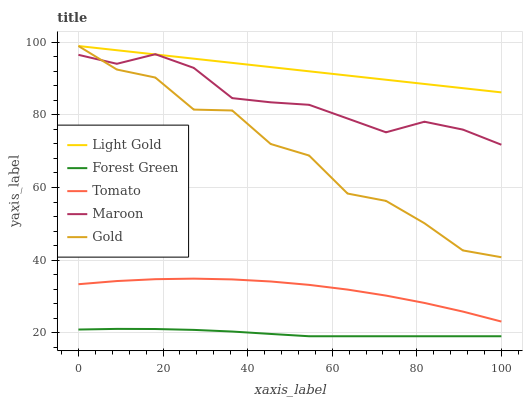Does Forest Green have the minimum area under the curve?
Answer yes or no. Yes. Does Light Gold have the maximum area under the curve?
Answer yes or no. Yes. Does Light Gold have the minimum area under the curve?
Answer yes or no. No. Does Forest Green have the maximum area under the curve?
Answer yes or no. No. Is Light Gold the smoothest?
Answer yes or no. Yes. Is Gold the roughest?
Answer yes or no. Yes. Is Forest Green the smoothest?
Answer yes or no. No. Is Forest Green the roughest?
Answer yes or no. No. Does Forest Green have the lowest value?
Answer yes or no. Yes. Does Light Gold have the lowest value?
Answer yes or no. No. Does Gold have the highest value?
Answer yes or no. Yes. Does Forest Green have the highest value?
Answer yes or no. No. Is Tomato less than Maroon?
Answer yes or no. Yes. Is Light Gold greater than Tomato?
Answer yes or no. Yes. Does Gold intersect Light Gold?
Answer yes or no. Yes. Is Gold less than Light Gold?
Answer yes or no. No. Is Gold greater than Light Gold?
Answer yes or no. No. Does Tomato intersect Maroon?
Answer yes or no. No. 